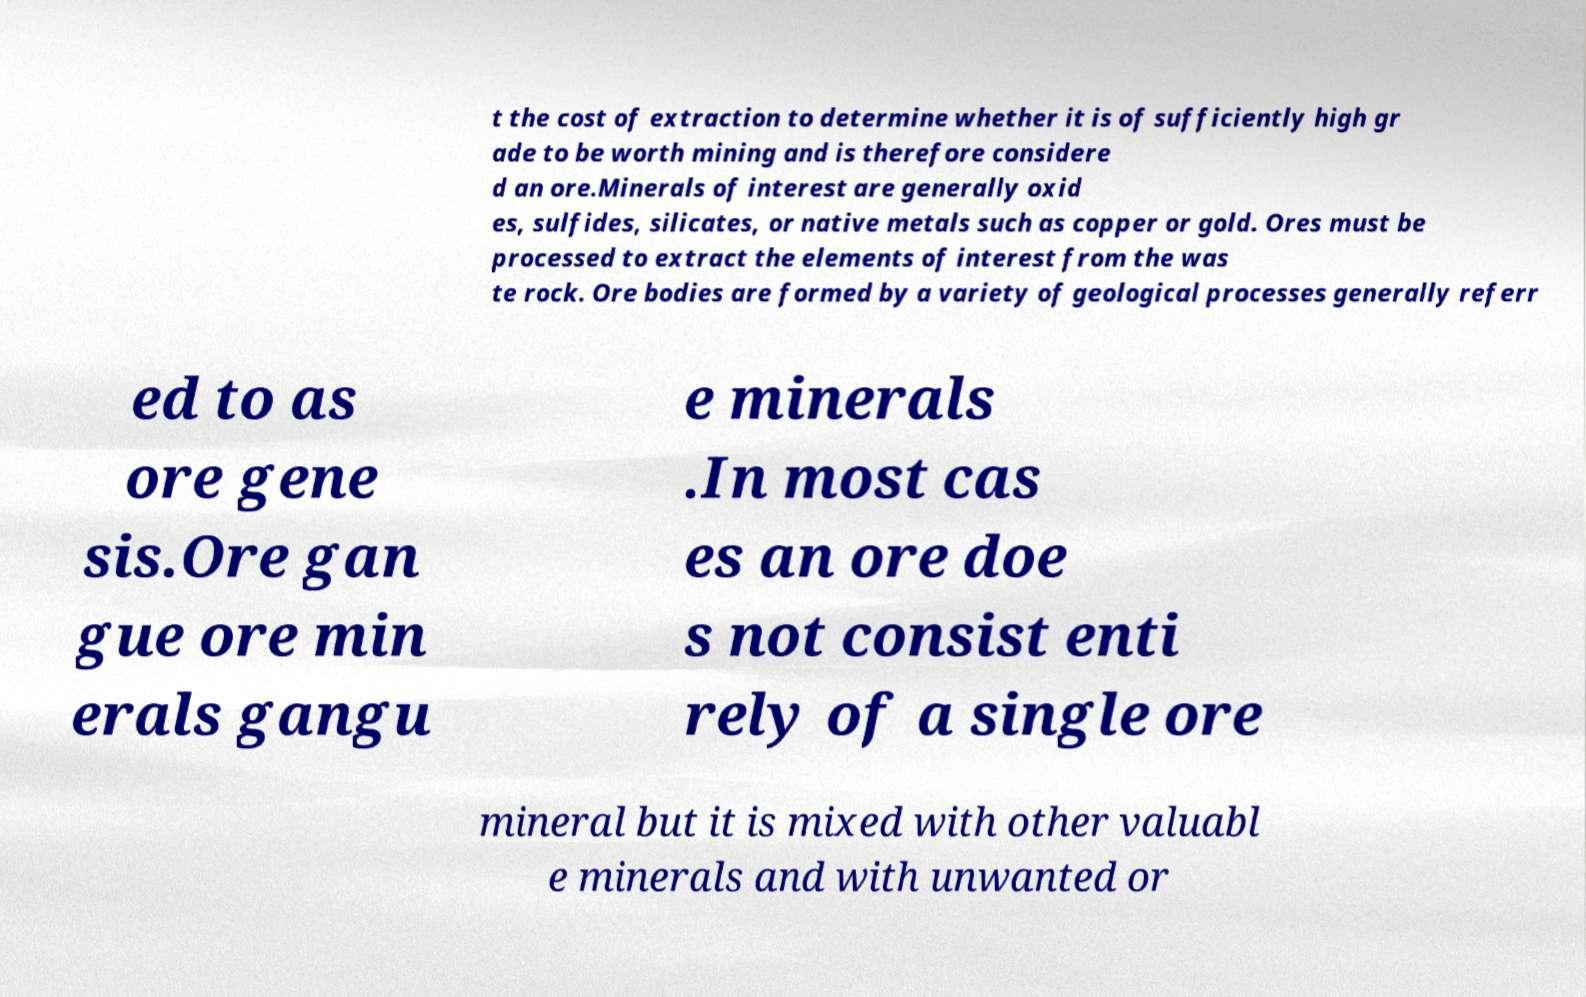Can you accurately transcribe the text from the provided image for me? t the cost of extraction to determine whether it is of sufficiently high gr ade to be worth mining and is therefore considere d an ore.Minerals of interest are generally oxid es, sulfides, silicates, or native metals such as copper or gold. Ores must be processed to extract the elements of interest from the was te rock. Ore bodies are formed by a variety of geological processes generally referr ed to as ore gene sis.Ore gan gue ore min erals gangu e minerals .In most cas es an ore doe s not consist enti rely of a single ore mineral but it is mixed with other valuabl e minerals and with unwanted or 